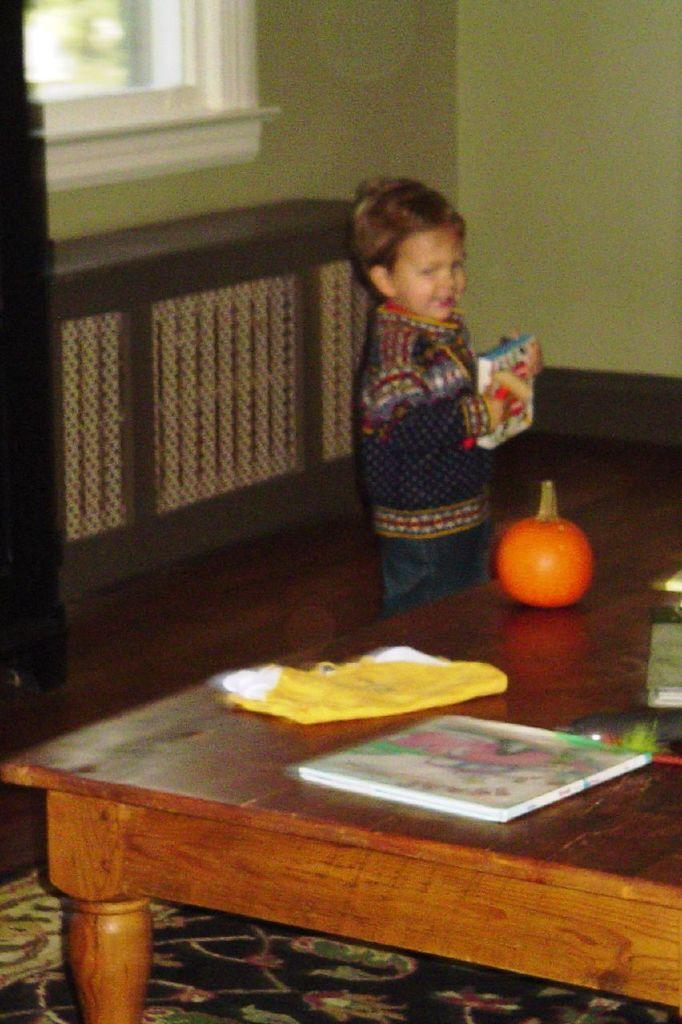In one or two sentences, can you explain what this image depicts? In the center we can see one person holding book. In the front we can see table on table we can see some objects. Coming to the background we can see wall and window. 